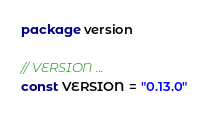Convert code to text. <code><loc_0><loc_0><loc_500><loc_500><_Go_>package version

// VERSION ...
const VERSION = "0.13.0"
</code> 